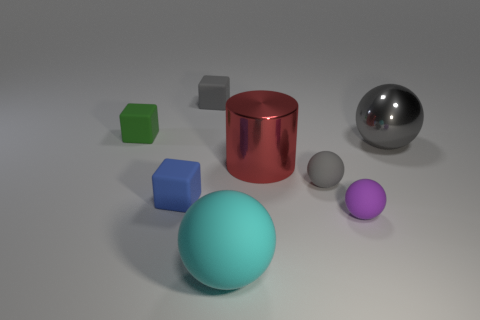Add 1 red metal cylinders. How many objects exist? 9 Subtract all cylinders. How many objects are left? 7 Add 4 red metallic objects. How many red metallic objects are left? 5 Add 6 small green matte objects. How many small green matte objects exist? 7 Subtract 1 red cylinders. How many objects are left? 7 Subtract all green matte cubes. Subtract all big cyan rubber things. How many objects are left? 6 